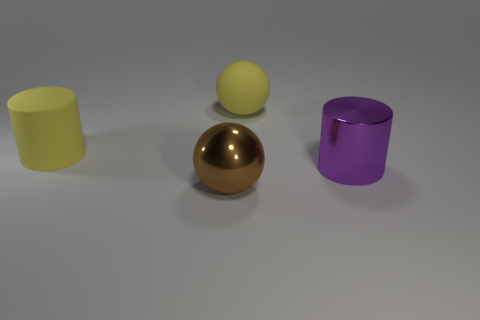Add 4 small metallic balls. How many objects exist? 8 Subtract 1 purple cylinders. How many objects are left? 3 Subtract all large balls. Subtract all brown metallic things. How many objects are left? 1 Add 1 spheres. How many spheres are left? 3 Add 2 big shiny balls. How many big shiny balls exist? 3 